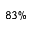<formula> <loc_0><loc_0><loc_500><loc_500>8 3 \%</formula> 